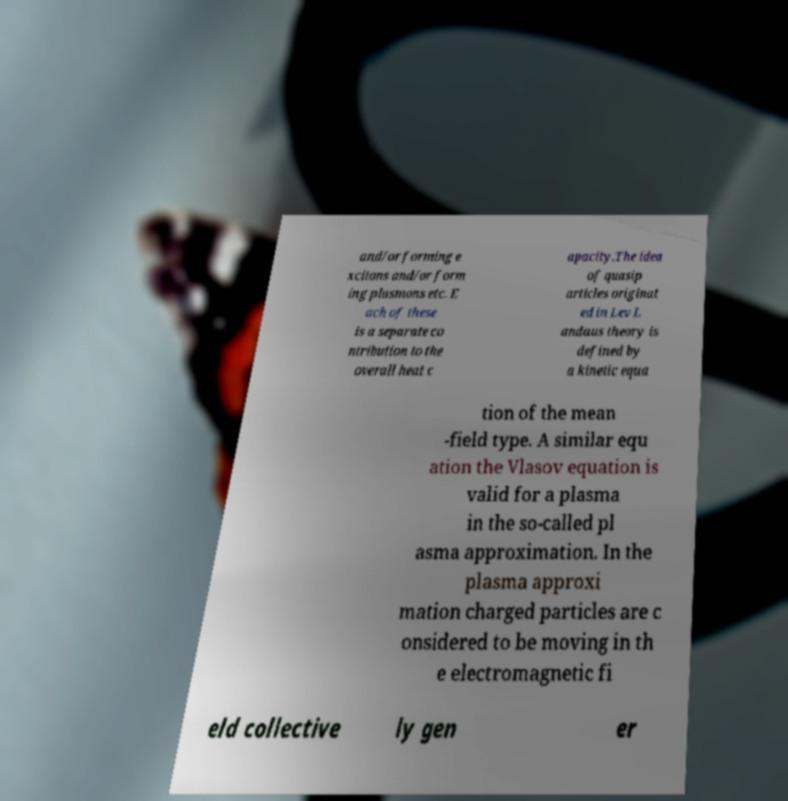Could you assist in decoding the text presented in this image and type it out clearly? and/or forming e xcitons and/or form ing plasmons etc. E ach of these is a separate co ntribution to the overall heat c apacity.The idea of quasip articles originat ed in Lev L andaus theory is defined by a kinetic equa tion of the mean -field type. A similar equ ation the Vlasov equation is valid for a plasma in the so-called pl asma approximation. In the plasma approxi mation charged particles are c onsidered to be moving in th e electromagnetic fi eld collective ly gen er 